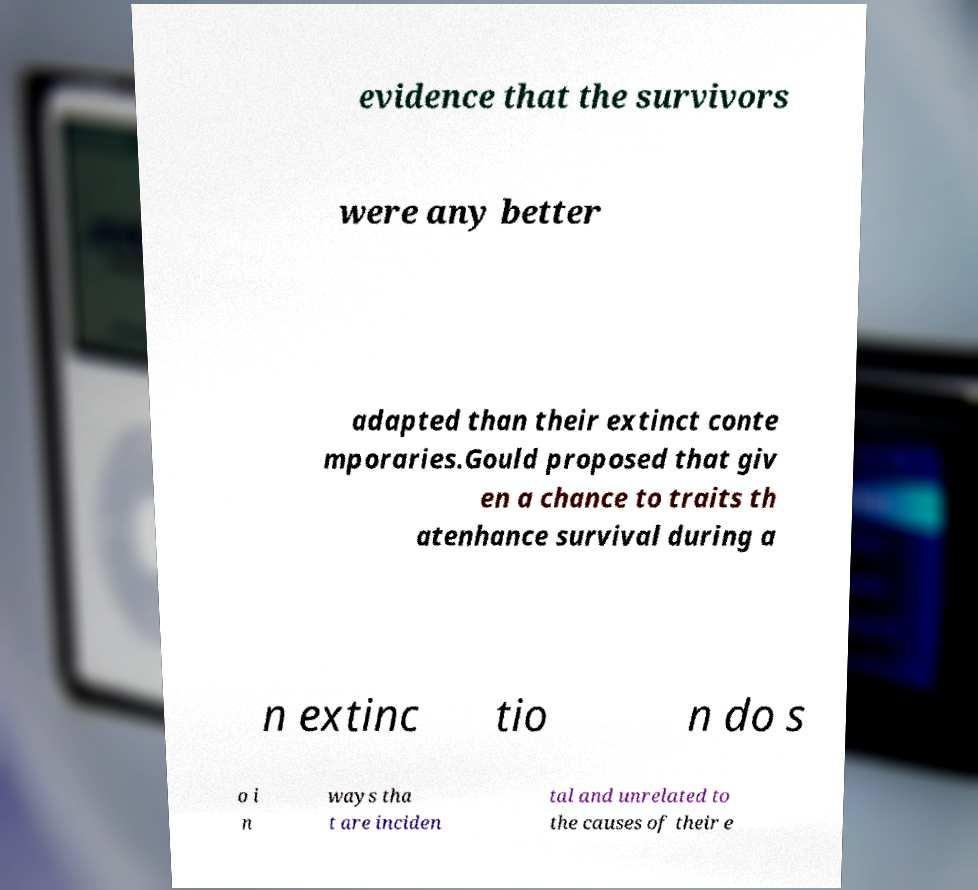Please identify and transcribe the text found in this image. evidence that the survivors were any better adapted than their extinct conte mporaries.Gould proposed that giv en a chance to traits th atenhance survival during a n extinc tio n do s o i n ways tha t are inciden tal and unrelated to the causes of their e 